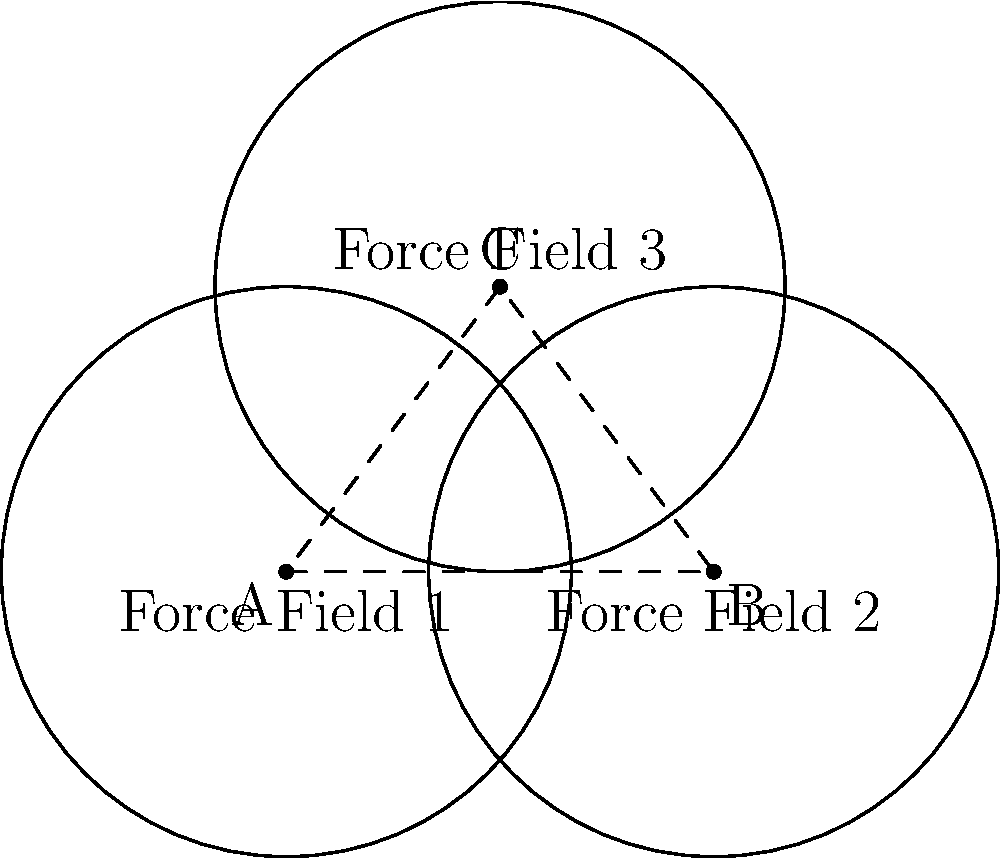In an eSports game, three circular force fields with equal radii of 2 units are centered at points A(0,0), B(3,0), and C(1.5,2). Calculate the area of the region where all three force fields intersect. To solve this problem, we'll follow these steps:

1) First, we need to determine if the three circles intersect. The distance between any two centers should be less than twice the radius (4 units) for an intersection to occur.

   AB = 3 units
   BC = AC ≈ 2.5 units (using the distance formula)

   Since all distances are less than 4, the circles do intersect.

2) The area of intersection can be found using the formula for the area of intersection of three circles:

   $$A = 3A_s - A_t$$

   Where $A_s$ is the area of a sector in each circle, and $A_t$ is the area of the triangle formed by the centers.

3) To find $A_s$, we need the central angle $\theta$ of the sector. This can be found using the cosine law:

   $$\cos(\frac{\theta}{2}) = \frac{r}{2r} = \frac{1}{2}$$

   $$\theta = 2 \arccos(\frac{1}{2}) = \frac{2\pi}{3}$$

4) The area of each sector is:

   $$A_s = \frac{1}{2}r^2\theta = \frac{1}{2} \cdot 2^2 \cdot \frac{2\pi}{3} = \frac{4\pi}{3}$$

5) The area of the triangle ABC can be found using Heron's formula:
   
   $$s = \frac{3 + 2.5 + 2.5}{2} = 4$$
   $$A_t = \sqrt{4(4-3)(4-2.5)(4-2.5)} \approx 2.18$$

6) Therefore, the area of intersection is:

   $$A = 3(\frac{4\pi}{3}) - 2.18 = 4\pi - 2.18 \approx 10.39$$
Answer: $4\pi - 2.18$ square units 